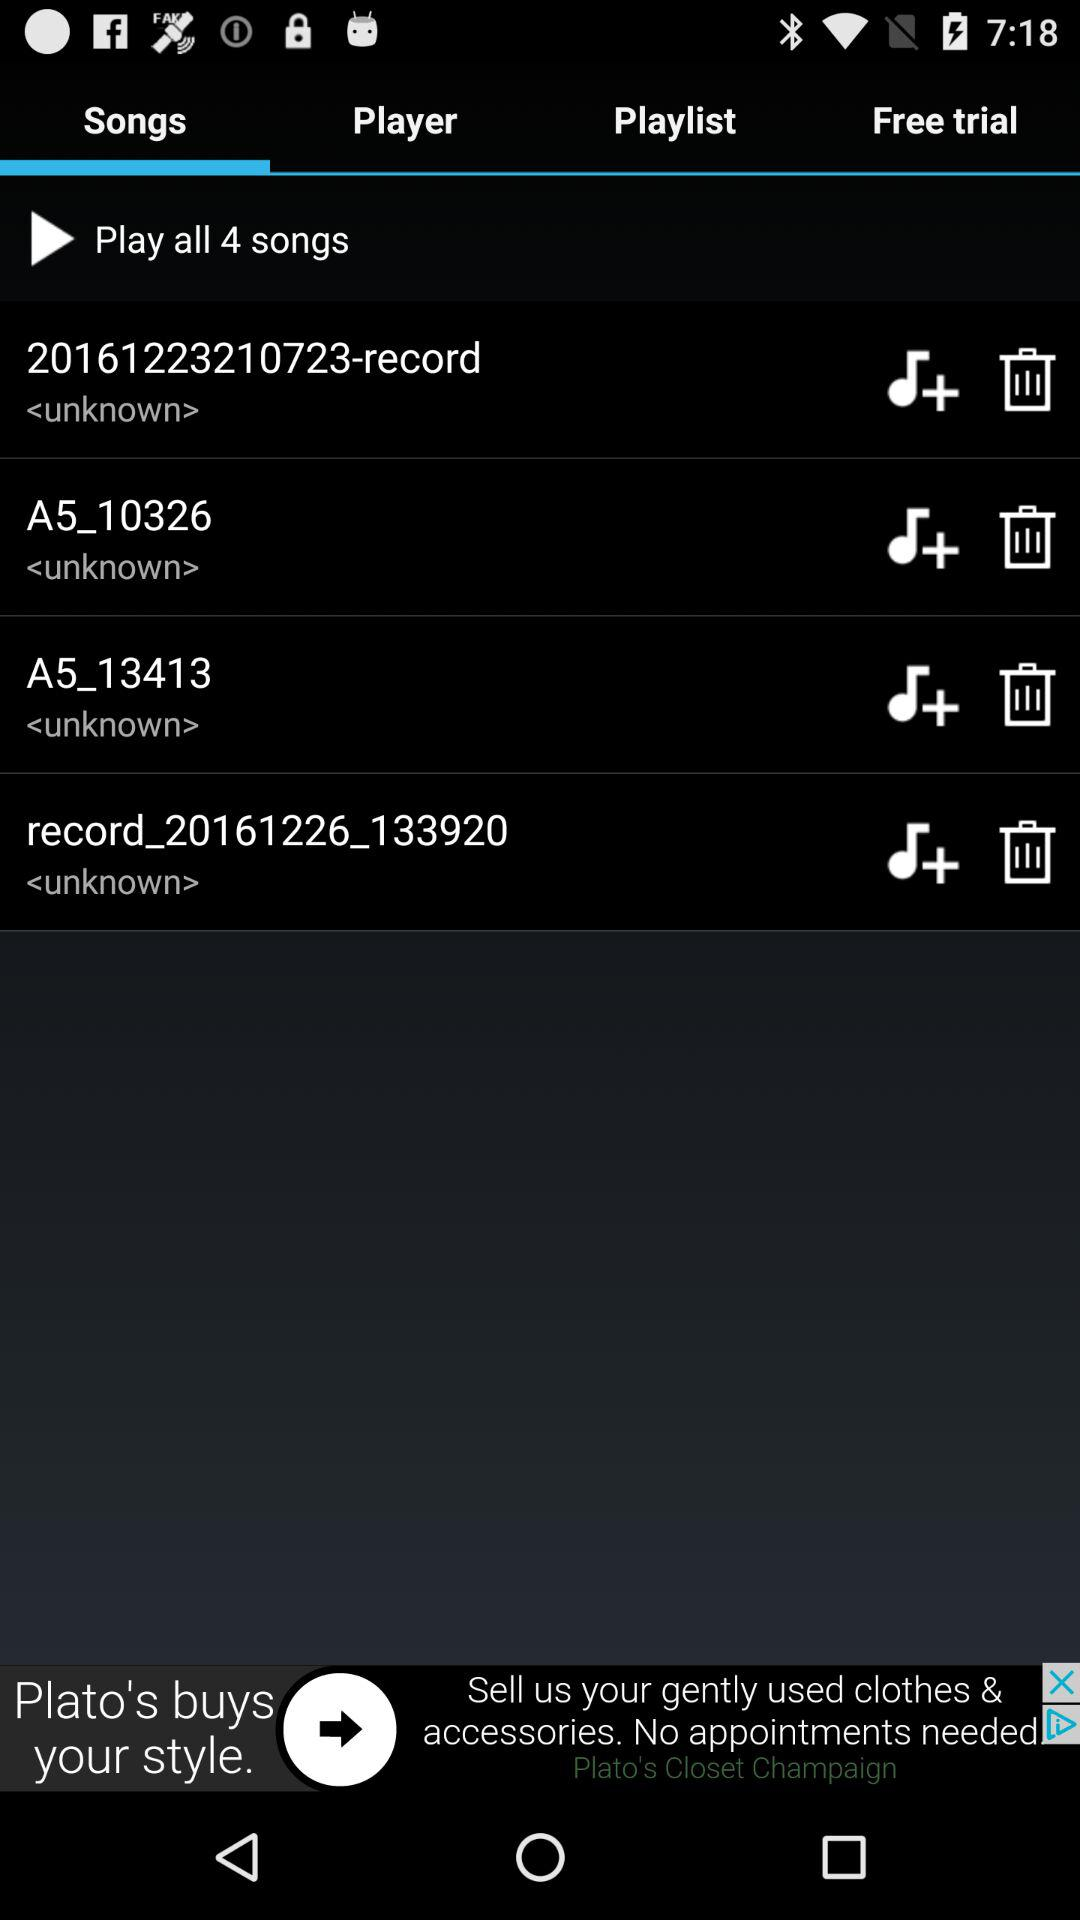How many songs are available? There are 4 songs available. 